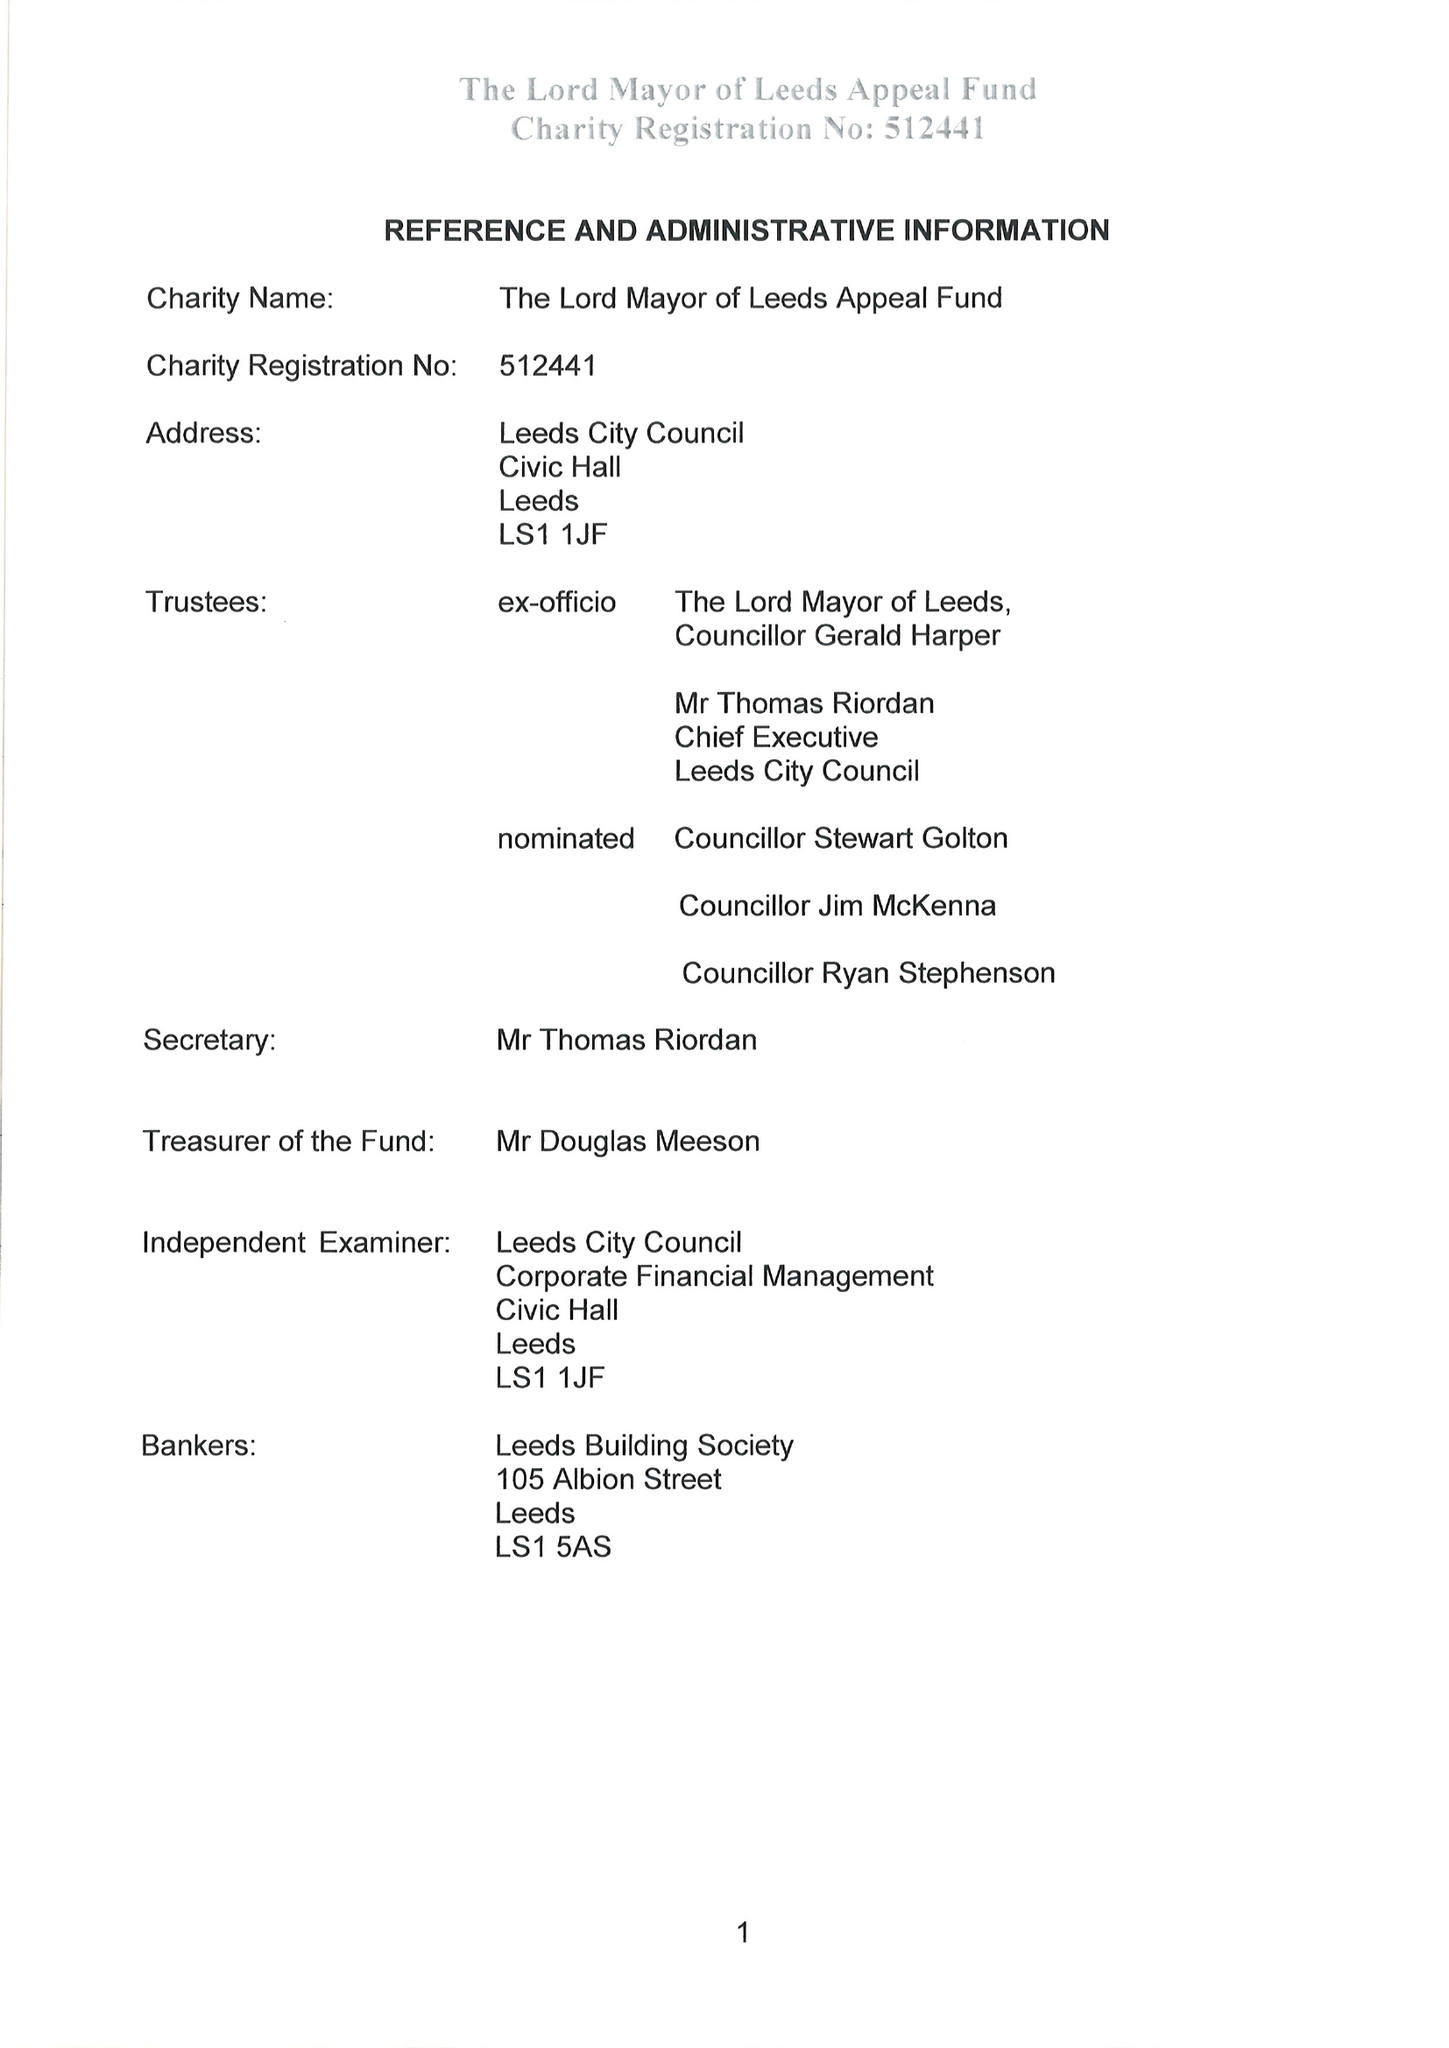What is the value for the spending_annually_in_british_pounds?
Answer the question using a single word or phrase. 46917.00 